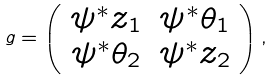<formula> <loc_0><loc_0><loc_500><loc_500>g = \left ( \begin{array} { c c } \psi ^ { * } z _ { 1 } & \psi ^ { * } \theta _ { 1 } \\ \psi ^ { * } \theta _ { 2 } & \psi ^ { * } z _ { 2 } \end{array} \right ) ,</formula> 